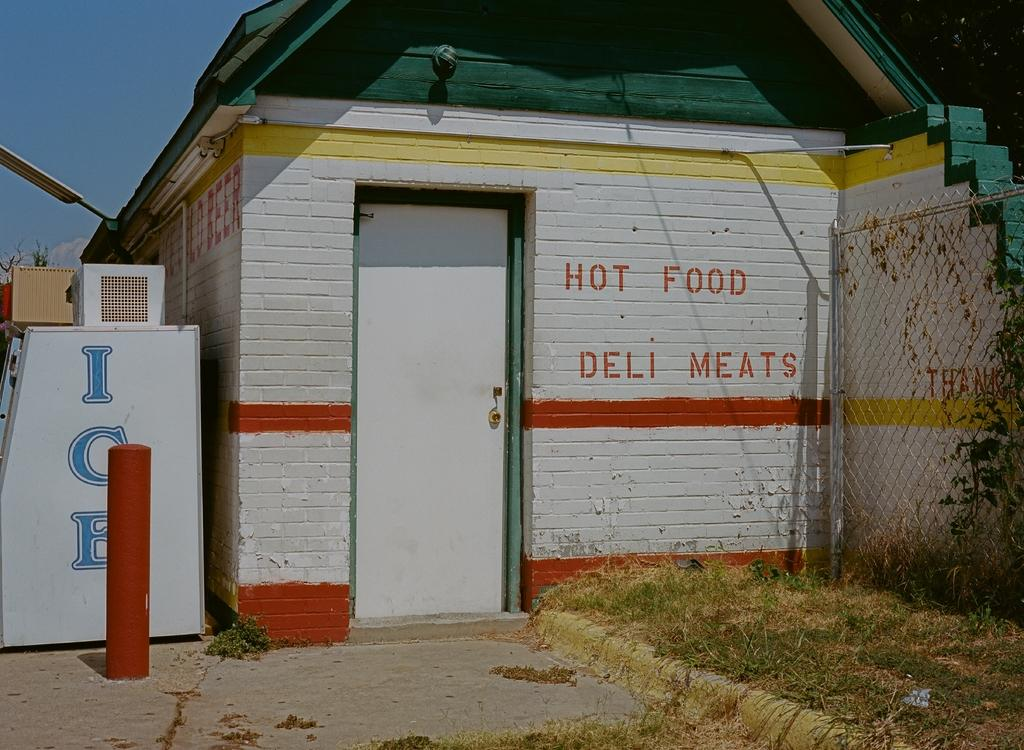What type of structure is visible in the image? There is a house in the image. What can be seen on the wall of the house? There is text on a wall in the image. What is located on the right side of the image? There is a fence on the right side of the image. What type of vegetation is present in the image? There is grass in the image. What type of grip does the house have on the land in the image? The image does not provide information about the house's grip on the land, as it is a static representation. 